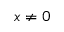<formula> <loc_0><loc_0><loc_500><loc_500>x \neq 0</formula> 